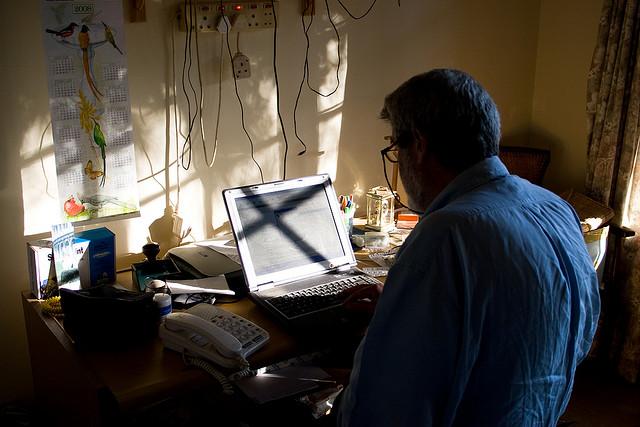Is the desk cluttered?
Be succinct. Yes. What is the person holding?
Keep it brief. Laptop. Is the a restaurant?
Give a very brief answer. No. Where is the outlet strip?
Concise answer only. Wall. Is the person in the picture a man or woman?
Be succinct. Man. Is the counter shiny?
Write a very short answer. No. Is this workstation cluttered or clean?
Quick response, please. Cluttered. Are the lights on?
Short answer required. No. 